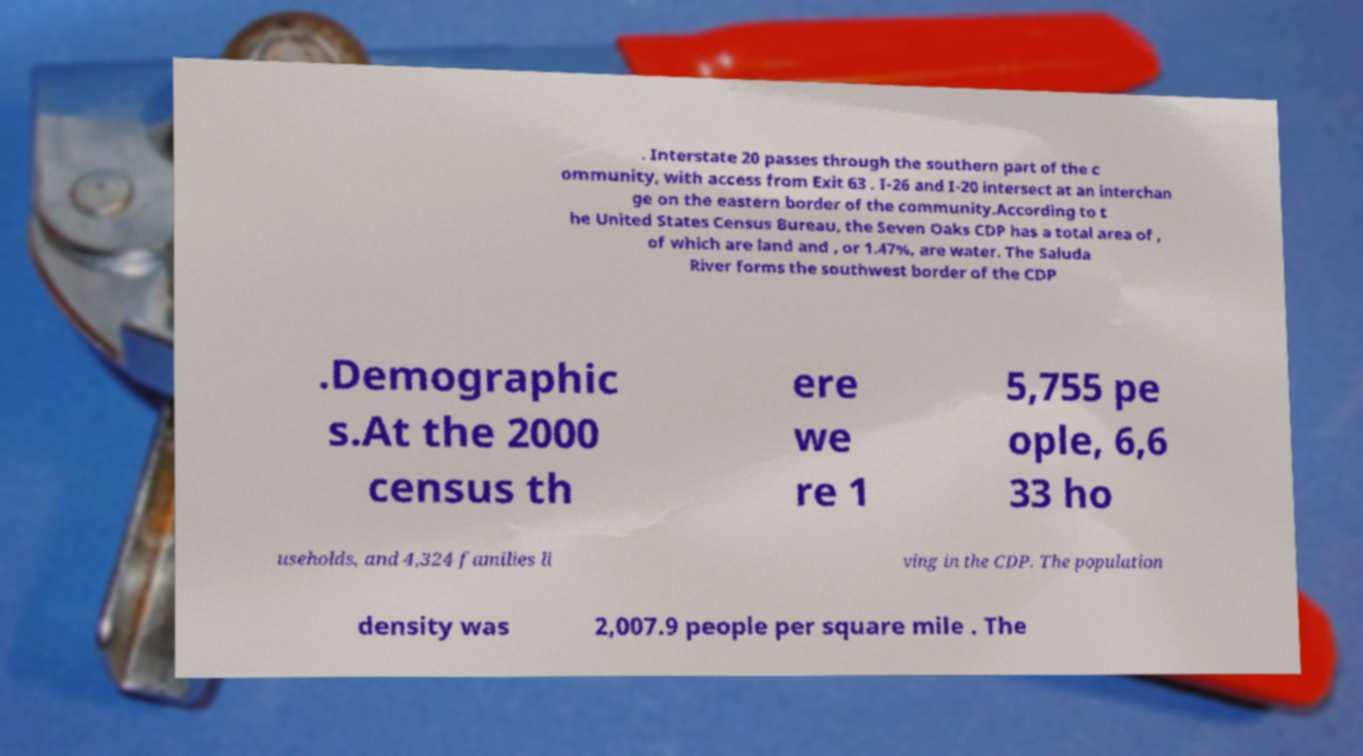What messages or text are displayed in this image? I need them in a readable, typed format. . Interstate 20 passes through the southern part of the c ommunity, with access from Exit 63 . I-26 and I-20 intersect at an interchan ge on the eastern border of the community.According to t he United States Census Bureau, the Seven Oaks CDP has a total area of , of which are land and , or 1.47%, are water. The Saluda River forms the southwest border of the CDP .Demographic s.At the 2000 census th ere we re 1 5,755 pe ople, 6,6 33 ho useholds, and 4,324 families li ving in the CDP. The population density was 2,007.9 people per square mile . The 